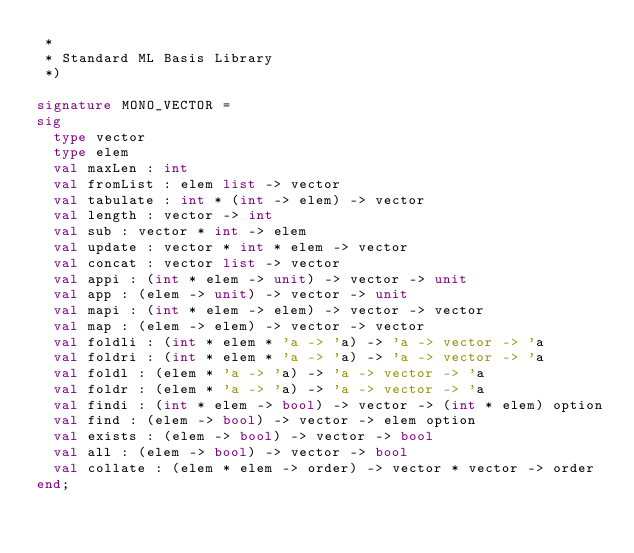<code> <loc_0><loc_0><loc_500><loc_500><_SML_> *
 * Standard ML Basis Library
 *)

signature MONO_VECTOR =
sig
  type vector
  type elem
  val maxLen : int
  val fromList : elem list -> vector
  val tabulate : int * (int -> elem) -> vector
  val length : vector -> int
  val sub : vector * int -> elem
  val update : vector * int * elem -> vector
  val concat : vector list -> vector
  val appi : (int * elem -> unit) -> vector -> unit
  val app : (elem -> unit) -> vector -> unit
  val mapi : (int * elem -> elem) -> vector -> vector
  val map : (elem -> elem) -> vector -> vector
  val foldli : (int * elem * 'a -> 'a) -> 'a -> vector -> 'a
  val foldri : (int * elem * 'a -> 'a) -> 'a -> vector -> 'a
  val foldl : (elem * 'a -> 'a) -> 'a -> vector -> 'a
  val foldr : (elem * 'a -> 'a) -> 'a -> vector -> 'a
  val findi : (int * elem -> bool) -> vector -> (int * elem) option
  val find : (elem -> bool) -> vector -> elem option
  val exists : (elem -> bool) -> vector -> bool
  val all : (elem -> bool) -> vector -> bool
  val collate : (elem * elem -> order) -> vector * vector -> order
end;
</code> 